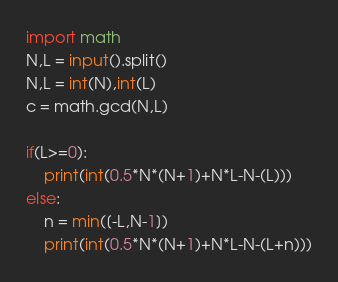Convert code to text. <code><loc_0><loc_0><loc_500><loc_500><_Python_>import math
N,L = input().split()
N,L = int(N),int(L)
c = math.gcd(N,L)

if(L>=0):
    print(int(0.5*N*(N+1)+N*L-N-(L)))
else:
    n = min([-L,N-1])
    print(int(0.5*N*(N+1)+N*L-N-(L+n)))</code> 